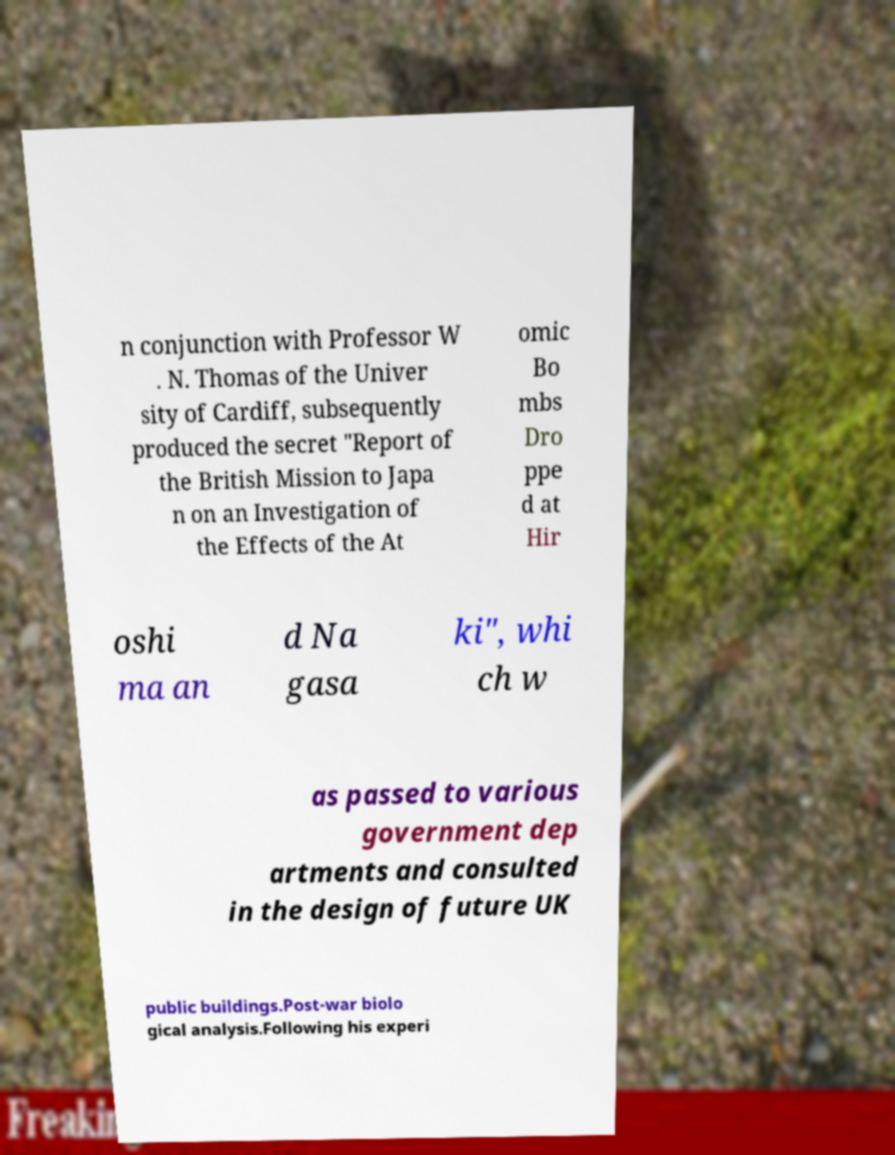Please identify and transcribe the text found in this image. n conjunction with Professor W . N. Thomas of the Univer sity of Cardiff, subsequently produced the secret "Report of the British Mission to Japa n on an Investigation of the Effects of the At omic Bo mbs Dro ppe d at Hir oshi ma an d Na gasa ki", whi ch w as passed to various government dep artments and consulted in the design of future UK public buildings.Post-war biolo gical analysis.Following his experi 